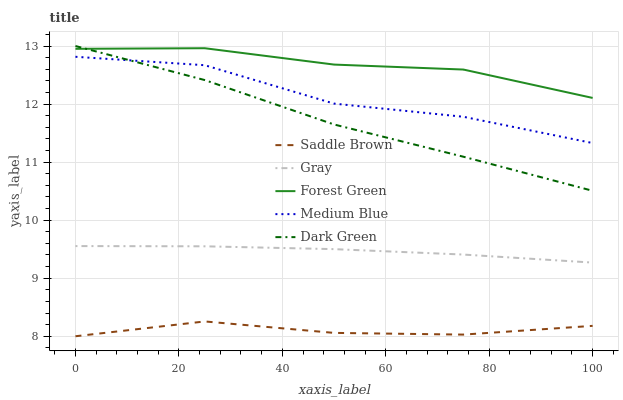Does Saddle Brown have the minimum area under the curve?
Answer yes or no. Yes. Does Forest Green have the maximum area under the curve?
Answer yes or no. Yes. Does Medium Blue have the minimum area under the curve?
Answer yes or no. No. Does Medium Blue have the maximum area under the curve?
Answer yes or no. No. Is Gray the smoothest?
Answer yes or no. Yes. Is Medium Blue the roughest?
Answer yes or no. Yes. Is Forest Green the smoothest?
Answer yes or no. No. Is Forest Green the roughest?
Answer yes or no. No. Does Saddle Brown have the lowest value?
Answer yes or no. Yes. Does Medium Blue have the lowest value?
Answer yes or no. No. Does Dark Green have the highest value?
Answer yes or no. Yes. Does Forest Green have the highest value?
Answer yes or no. No. Is Gray less than Dark Green?
Answer yes or no. Yes. Is Dark Green greater than Gray?
Answer yes or no. Yes. Does Forest Green intersect Dark Green?
Answer yes or no. Yes. Is Forest Green less than Dark Green?
Answer yes or no. No. Is Forest Green greater than Dark Green?
Answer yes or no. No. Does Gray intersect Dark Green?
Answer yes or no. No. 